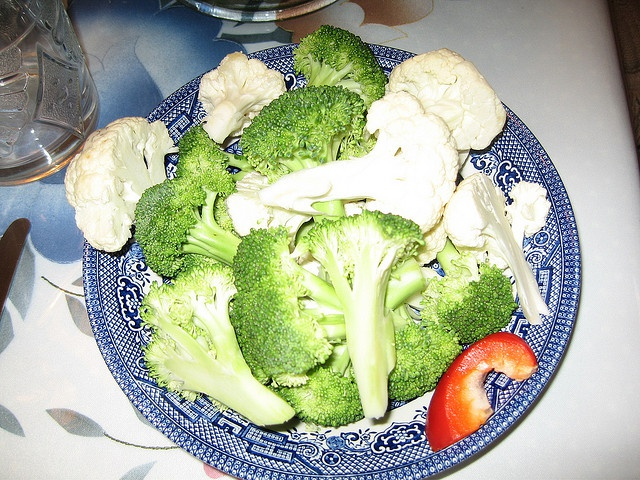Describe the objects in this image and their specific colors. I can see broccoli in black, khaki, beige, lightgreen, and olive tones, cup in black, gray, and darkgray tones, and knife in black, gray, and maroon tones in this image. 